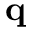Convert formula to latex. <formula><loc_0><loc_0><loc_500><loc_500>q</formula> 